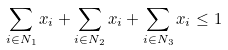<formula> <loc_0><loc_0><loc_500><loc_500>\sum _ { i \in N _ { 1 } } x _ { i } + \sum _ { i \in N _ { 2 } } x _ { i } + \sum _ { i \in N _ { 3 } } x _ { i } \leq 1</formula> 